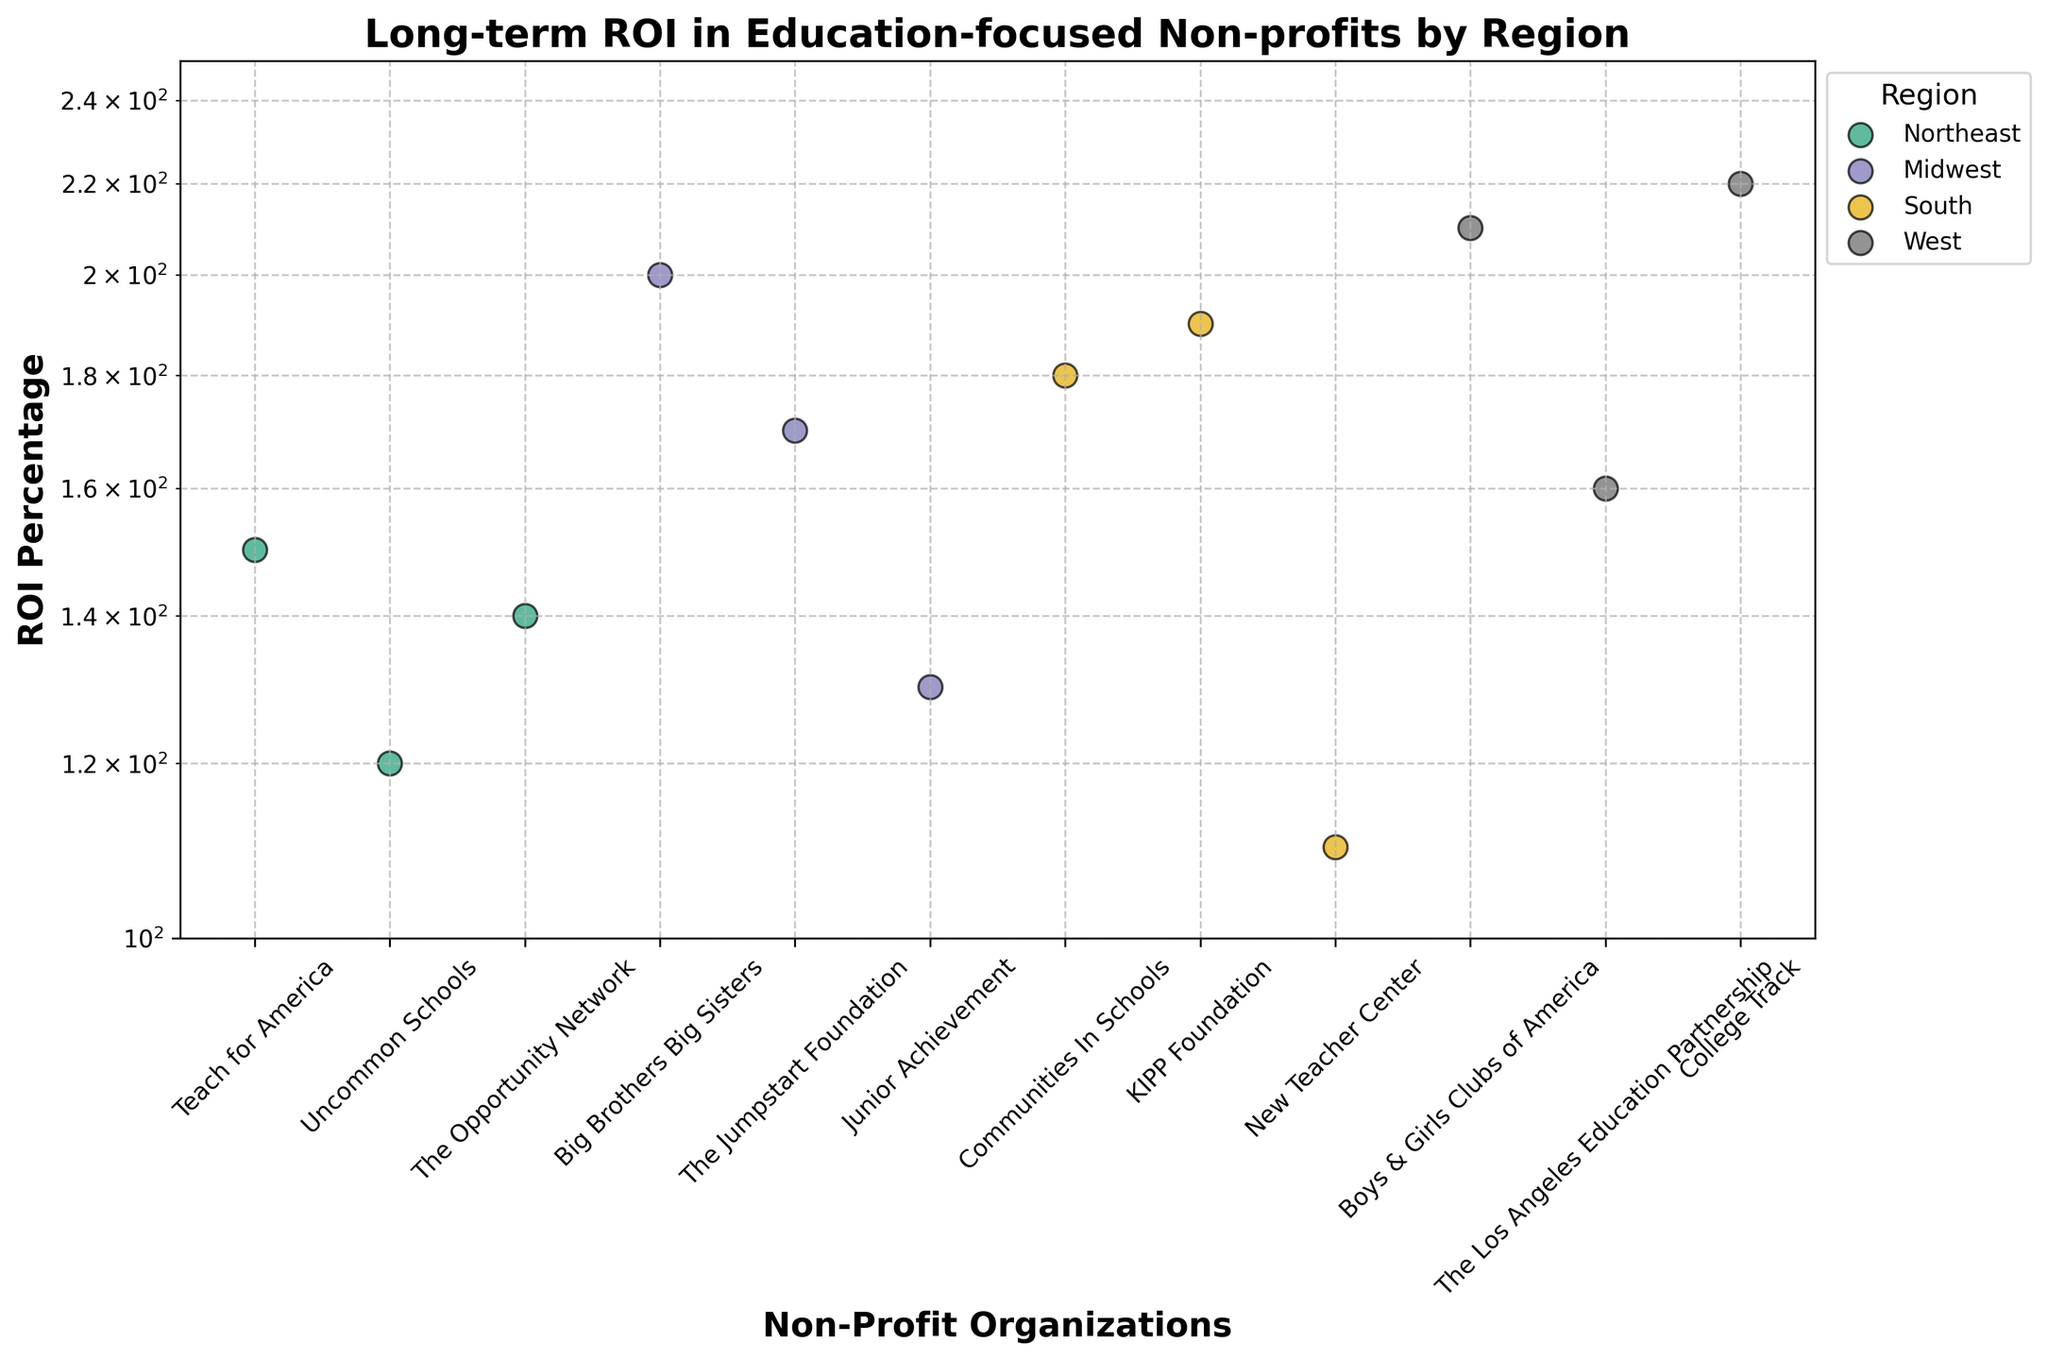What's the title of the plot? The title of the plot is located at the top and visually stands out due to its size and bold font.
Answer: Long-term ROI in Education-focused Non-profits by Region What type of scale is used on the y-axis? The y-axis features numbers like 100, 150, and 200, and these numbers are not evenly spaced, indicating a logarithmic scale.
Answer: Logarithmic Which region has the highest ROI Percentage for any non-profit organization? The scatter points labeled by regions are color-coded, and the highest point (220) can be seen for College Track in the West region.
Answer: West Which non-profit organization in the Midwest has the highest ROI Percentage? Within the Midwest region, each non-profit is plotted. The highest ROI (200) corresponds to Big Brothers Big Sisters.
Answer: Big Brothers Big Sisters How many non-profits are represented in the South region? By identifying the colors and labels associated with the South region, one can count the distinct scatter points.
Answer: 3 What’s the average ROI Percentage of the non-profits in the Northeast region? Identify the ROI values for all non-profits in the Northeast region (150, 120, 140). Then sum them (410) and divide by the number of points (3).
Answer: 136.7 Which non-profit organization has the lowest ROI Percentage? By comparing the height of all the points, the lowest point corresponds to 110 for New Teacher Center in the South region.
Answer: New Teacher Center Is there a significant difference in ROI Percentages between any two regions? To determine this, compare the range of ROI percentages within each region. The South and West both have points around 180-220, while the Northeast has points lower from 120-150.
Answer: Yes How are the non-profit organizations grouped in the plot? By looking at the color grouping and the legend, non-profits are grouped based on their regions.
Answer: By Region What’s the range of ROI Percentages for the non-profits in the West? Identify the highest (220 for College Track) and the lowest (160 for LA Education Partnership) ROI in the West region. Calculate the difference (220 - 160).
Answer: 60 